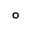<formula> <loc_0><loc_0><loc_500><loc_500>^ { \circ }</formula> 